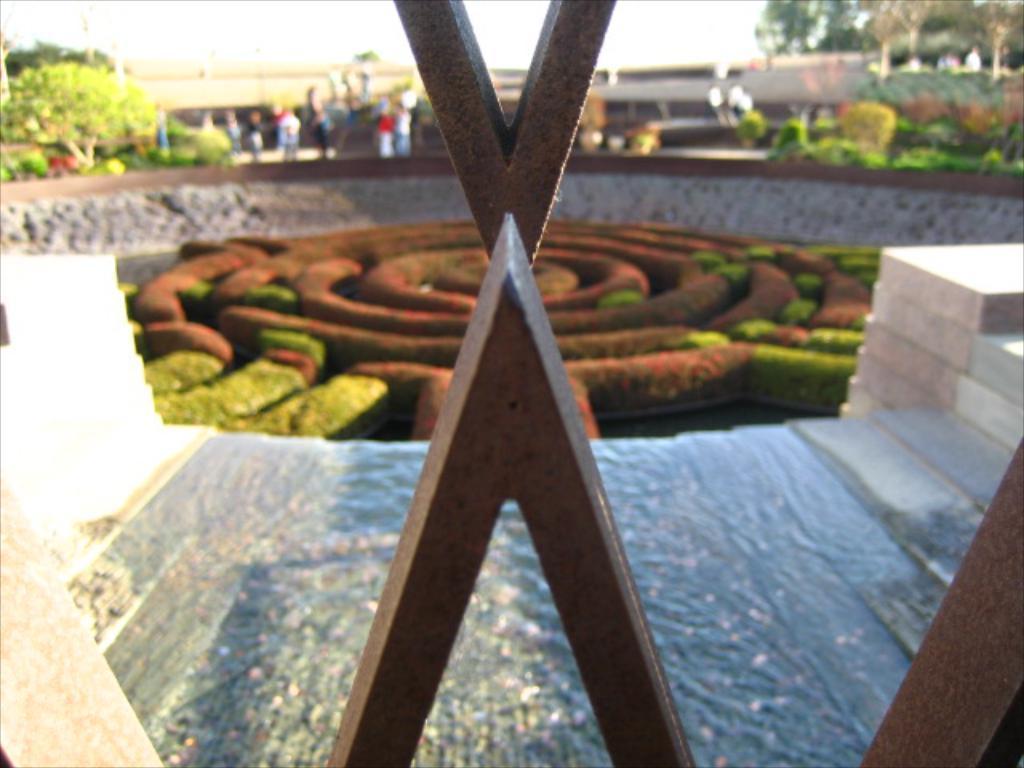How would you summarize this image in a sentence or two? In this image we can see a garden, stairs, a group of persons, building, trees and sky. 